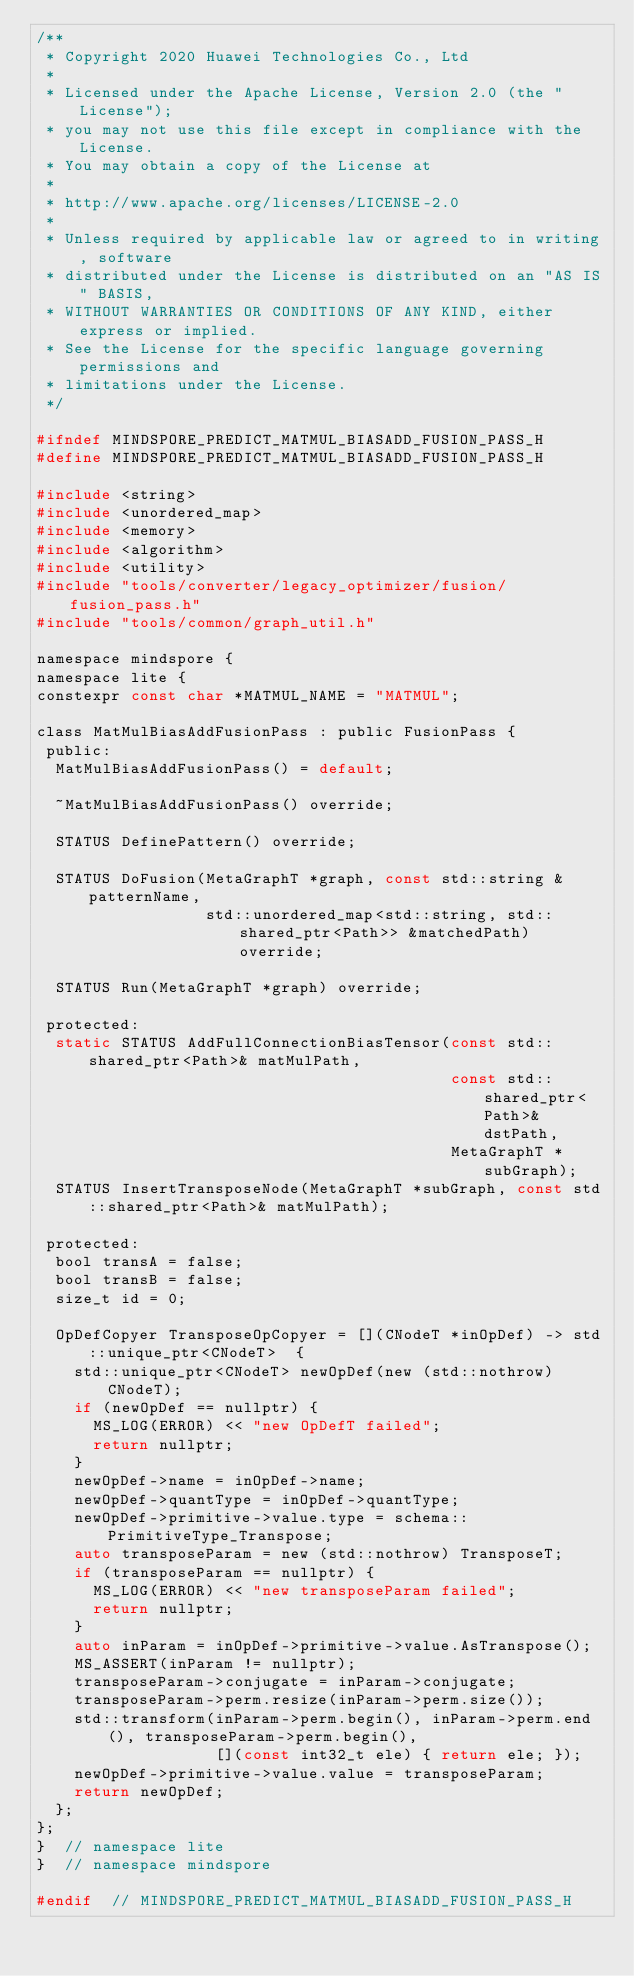<code> <loc_0><loc_0><loc_500><loc_500><_C_>/**
 * Copyright 2020 Huawei Technologies Co., Ltd
 *
 * Licensed under the Apache License, Version 2.0 (the "License");
 * you may not use this file except in compliance with the License.
 * You may obtain a copy of the License at
 *
 * http://www.apache.org/licenses/LICENSE-2.0
 *
 * Unless required by applicable law or agreed to in writing, software
 * distributed under the License is distributed on an "AS IS" BASIS,
 * WITHOUT WARRANTIES OR CONDITIONS OF ANY KIND, either express or implied.
 * See the License for the specific language governing permissions and
 * limitations under the License.
 */

#ifndef MINDSPORE_PREDICT_MATMUL_BIASADD_FUSION_PASS_H
#define MINDSPORE_PREDICT_MATMUL_BIASADD_FUSION_PASS_H

#include <string>
#include <unordered_map>
#include <memory>
#include <algorithm>
#include <utility>
#include "tools/converter/legacy_optimizer/fusion/fusion_pass.h"
#include "tools/common/graph_util.h"

namespace mindspore {
namespace lite {
constexpr const char *MATMUL_NAME = "MATMUL";

class MatMulBiasAddFusionPass : public FusionPass {
 public:
  MatMulBiasAddFusionPass() = default;

  ~MatMulBiasAddFusionPass() override;

  STATUS DefinePattern() override;

  STATUS DoFusion(MetaGraphT *graph, const std::string &patternName,
                  std::unordered_map<std::string, std::shared_ptr<Path>> &matchedPath) override;

  STATUS Run(MetaGraphT *graph) override;

 protected:
  static STATUS AddFullConnectionBiasTensor(const std::shared_ptr<Path>& matMulPath,
                                            const std::shared_ptr<Path>& dstPath,
                                            MetaGraphT *subGraph);
  STATUS InsertTransposeNode(MetaGraphT *subGraph, const std::shared_ptr<Path>& matMulPath);

 protected:
  bool transA = false;
  bool transB = false;
  size_t id = 0;

  OpDefCopyer TransposeOpCopyer = [](CNodeT *inOpDef) -> std::unique_ptr<CNodeT>  {
    std::unique_ptr<CNodeT> newOpDef(new (std::nothrow) CNodeT);
    if (newOpDef == nullptr) {
      MS_LOG(ERROR) << "new OpDefT failed";
      return nullptr;
    }
    newOpDef->name = inOpDef->name;
    newOpDef->quantType = inOpDef->quantType;
    newOpDef->primitive->value.type = schema::PrimitiveType_Transpose;
    auto transposeParam = new (std::nothrow) TransposeT;
    if (transposeParam == nullptr) {
      MS_LOG(ERROR) << "new transposeParam failed";
      return nullptr;
    }
    auto inParam = inOpDef->primitive->value.AsTranspose();
    MS_ASSERT(inParam != nullptr);
    transposeParam->conjugate = inParam->conjugate;
    transposeParam->perm.resize(inParam->perm.size());
    std::transform(inParam->perm.begin(), inParam->perm.end(), transposeParam->perm.begin(),
                   [](const int32_t ele) { return ele; });
    newOpDef->primitive->value.value = transposeParam;
    return newOpDef;
  };
};
}  // namespace lite
}  // namespace mindspore

#endif  // MINDSPORE_PREDICT_MATMUL_BIASADD_FUSION_PASS_H

</code> 